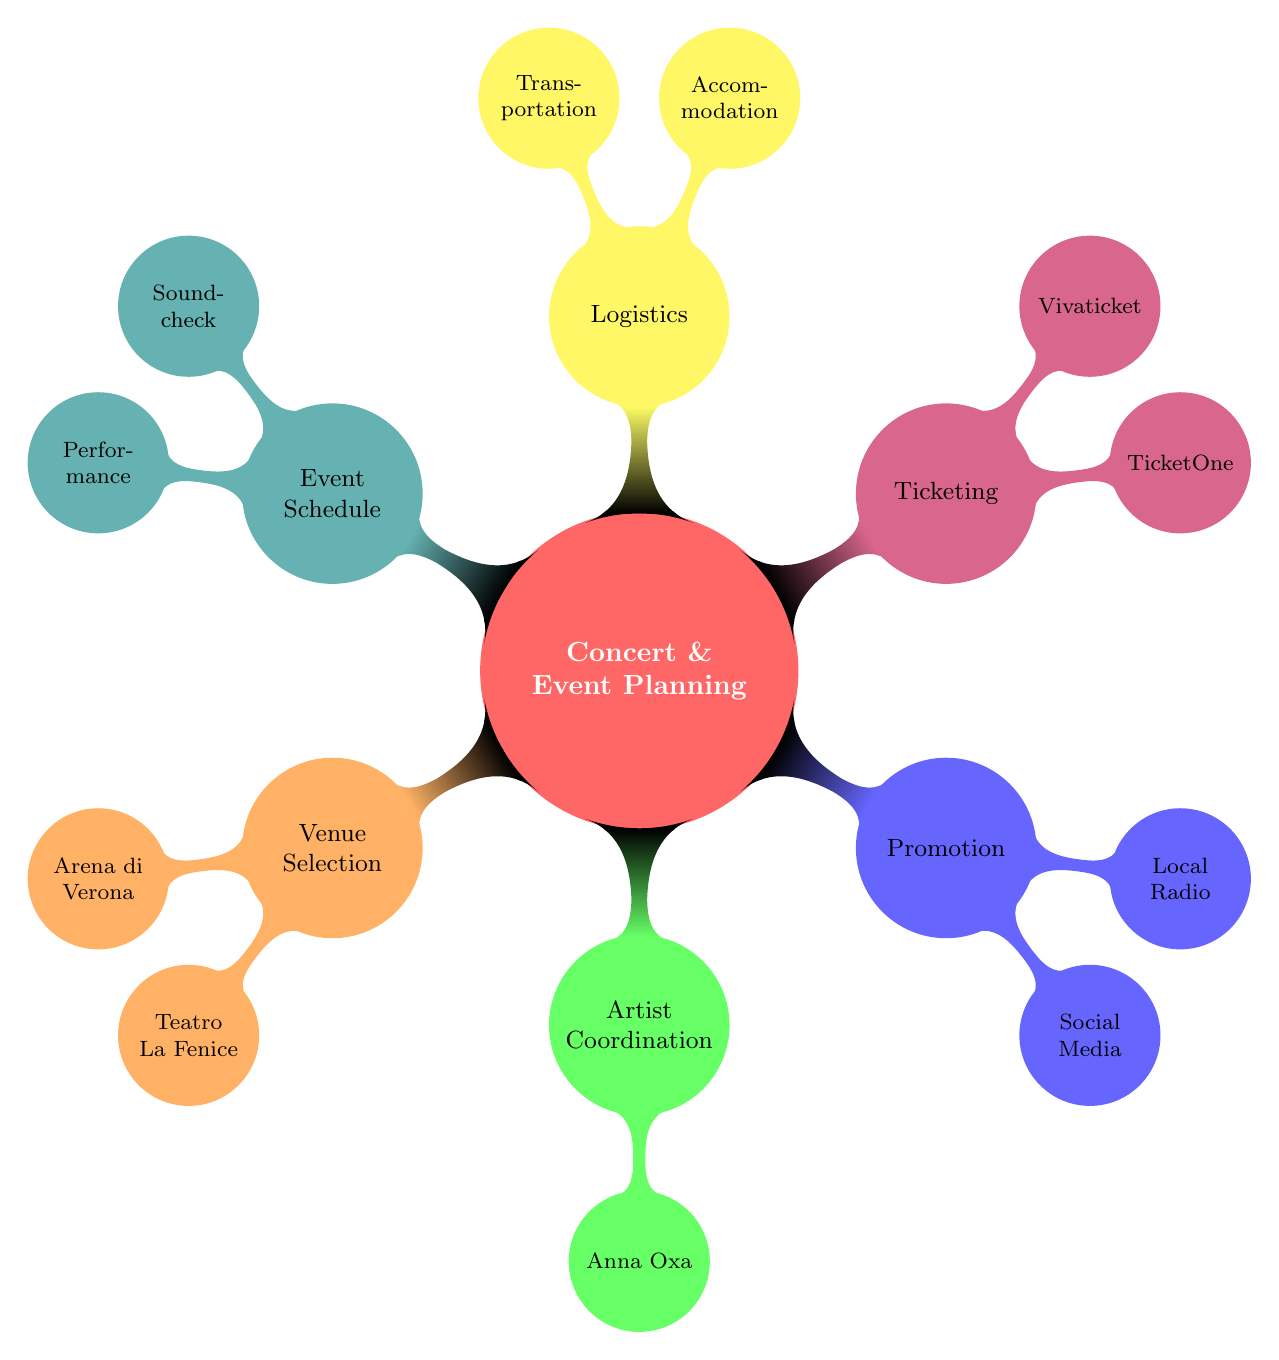What are the two venue options listed? The diagram indicates two options for venue selection: Arena di Verona and Teatro La Fenice.
Answer: Arena di Verona, Teatro La Fenice How many artists are coordinated in this plan? The diagram shows that there is one artist, Anna Oxa, mentioned under artist coordination.
Answer: 1 What is the capacity of the Arena di Verona? The diagram provides the capacity of the Arena di Verona, which is stated as 10,000.
Answer: 10,000 Which platform is mentioned for ticketing? The diagram lists two platforms under ticketing, including TicketOne and Vivaticket.
Answer: TicketOne, Vivaticket What emergency plan is outlined in the security section? The security section talks about the emergency plan, which involves coordination with local authorities.
Answer: Coordination with Local Authorities What are the two types of transportation listed in the logistics section? The diagram details the transportation options as Tour Buses and Private Flights within the logistics section.
Answer: Tour Buses, Private Flights What is the performance start time according to the event schedule? The event schedule specifies that the performance starts at 21:00.
Answer: 21:00 How many promotion channels are listed? The diagram identifies three channels under promotion, which are Social Media, Local Radio, and Music Magazines.
Answer: 3 What are the accommodation options mentioned? The logistics section of the diagram includes two accommodation options: Grand Hotel et de Milan and Hotel Danieli.
Answer: Grand Hotel et de Milan, Hotel Danieli 